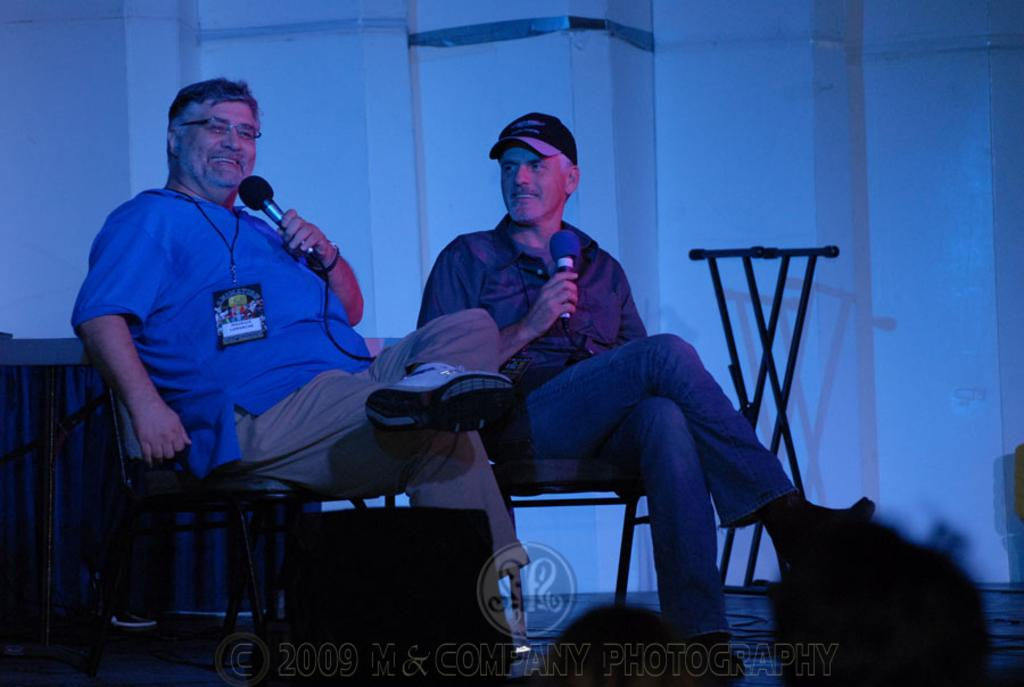How many people are in the image? There are two men in the image. What are the men doing in the image? The men are sitting in chairs and holding microphones in their hands. What can be seen in the background of the image? There is a wall in the background of the image. What type of screw can be seen on the wall in the image? There is no screw visible on the wall in the image. What type of wine is being served to the men in the image? There is no wine present in the image; the men are holding microphones. 